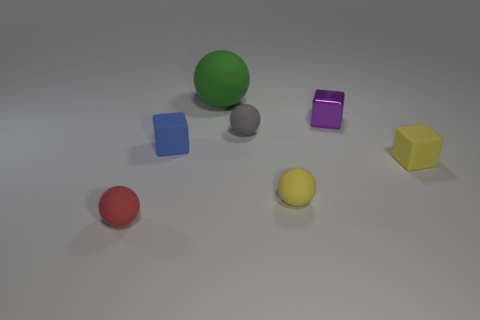Add 2 yellow matte objects. How many objects exist? 9 Subtract all small yellow rubber cubes. How many cubes are left? 2 Subtract all gray spheres. How many spheres are left? 3 Subtract all spheres. How many objects are left? 3 Subtract 0 purple balls. How many objects are left? 7 Subtract all purple balls. Subtract all purple blocks. How many balls are left? 4 Subtract all tiny matte spheres. Subtract all cyan cylinders. How many objects are left? 4 Add 5 rubber blocks. How many rubber blocks are left? 7 Add 1 tiny purple blocks. How many tiny purple blocks exist? 2 